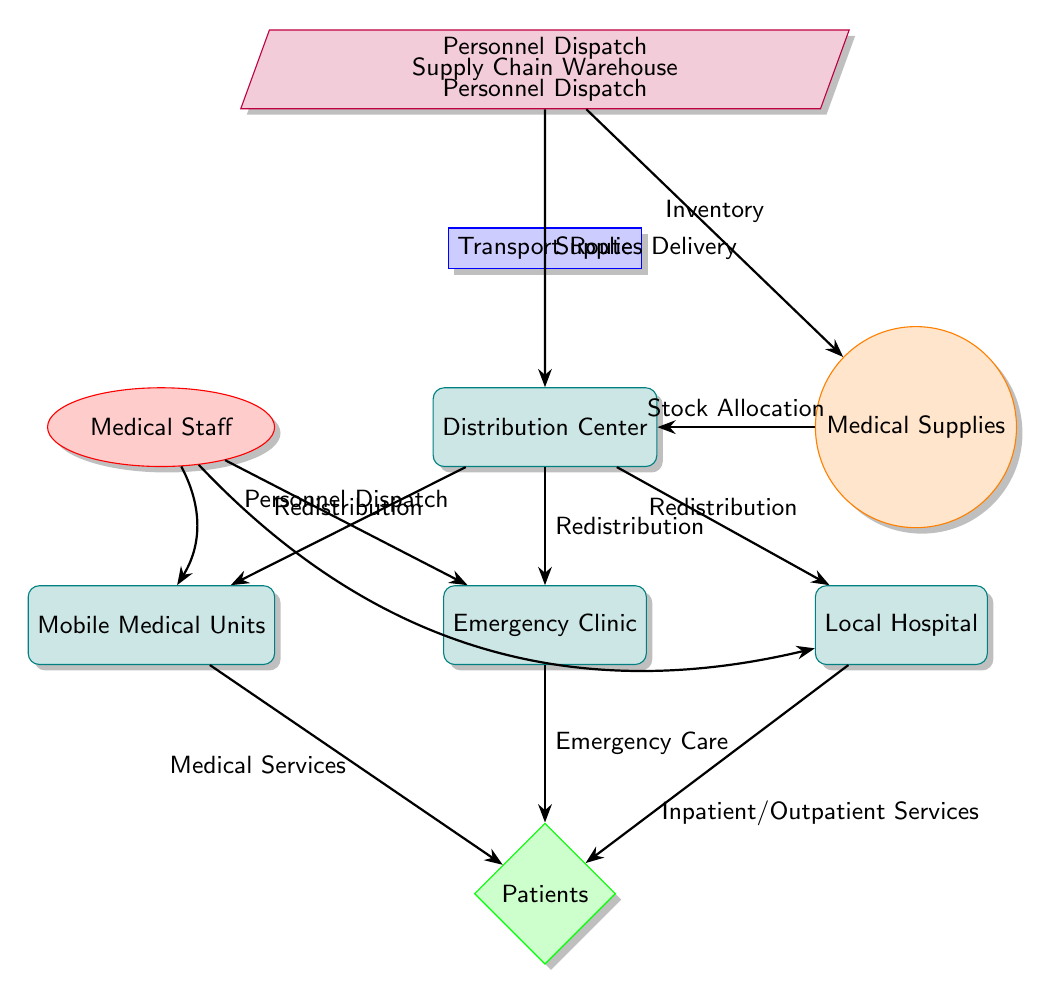What is the primary purpose of the Supply Chain Warehouse? The Supply Chain Warehouse is designed for storing and managing medical supplies before they are distributed. According to the diagram, it serves as the initial point where supplies are gathered before they are transported to the Distribution Center.
Answer: Supplies Delivery How many distribution locations are represented in the diagram? There are three distribution locations connected to the Distribution Center: Mobile Medical Units, Emergency Clinic, and Local Hospital. These are the points where medical services are redirected to patients.
Answer: Three What type of node represents the Medical Staff? The Medical Staff is represented as an ellipse in the diagram. It indicates the human resources available in the healthcare response system.
Answer: Human What flows from the Distribution Center to the Mobile Medical Units? The flow from the Distribution Center to the Mobile Medical Units is labeled as "Redistribution." This indicates that supplies are rerouted here to provide medical services.
Answer: Redistribution Which node connects directly to the Patients for Emergency Care? The node that connects directly to the Patients for Emergency Care is the Emergency Clinic. This node specifically addresses urgent medical needs of patients.
Answer: Emergency Clinic What type of services does the Local Hospital provide according to the diagram? The Local Hospital provides Inpatient/Outpatient Services as indicated by the label on the arrow directed towards the Patients. This means they can accommodate both types of healthcare services.
Answer: Inpatient/Outpatient Services How does Medical Supplies relate to the Supply Chain Warehouse? Medical Supplies are directly sourced from the Supply Chain Warehouse and allocated to the Distribution Center, as indicated by the arrow labeled "Inventory." This reflects the initial collection and organization of supplies.
Answer: Stock Allocation What role does the Transport Route play in the diagram? The Transport Route serves as a connection linking the Supply Chain Warehouse to the Distribution Center. It represents the pathway along which supplies are delivered, facilitating movement within the supply chain.
Answer: Transport Route How do Medical Staff get dispatched to the Emergency Clinic? Medical Staff are shown to be dispatched to the Emergency Clinic via the arrow labeled "Personnel Dispatch," indicating a route for personnel to reach the clinic and provide care.
Answer: Personnel Dispatch 